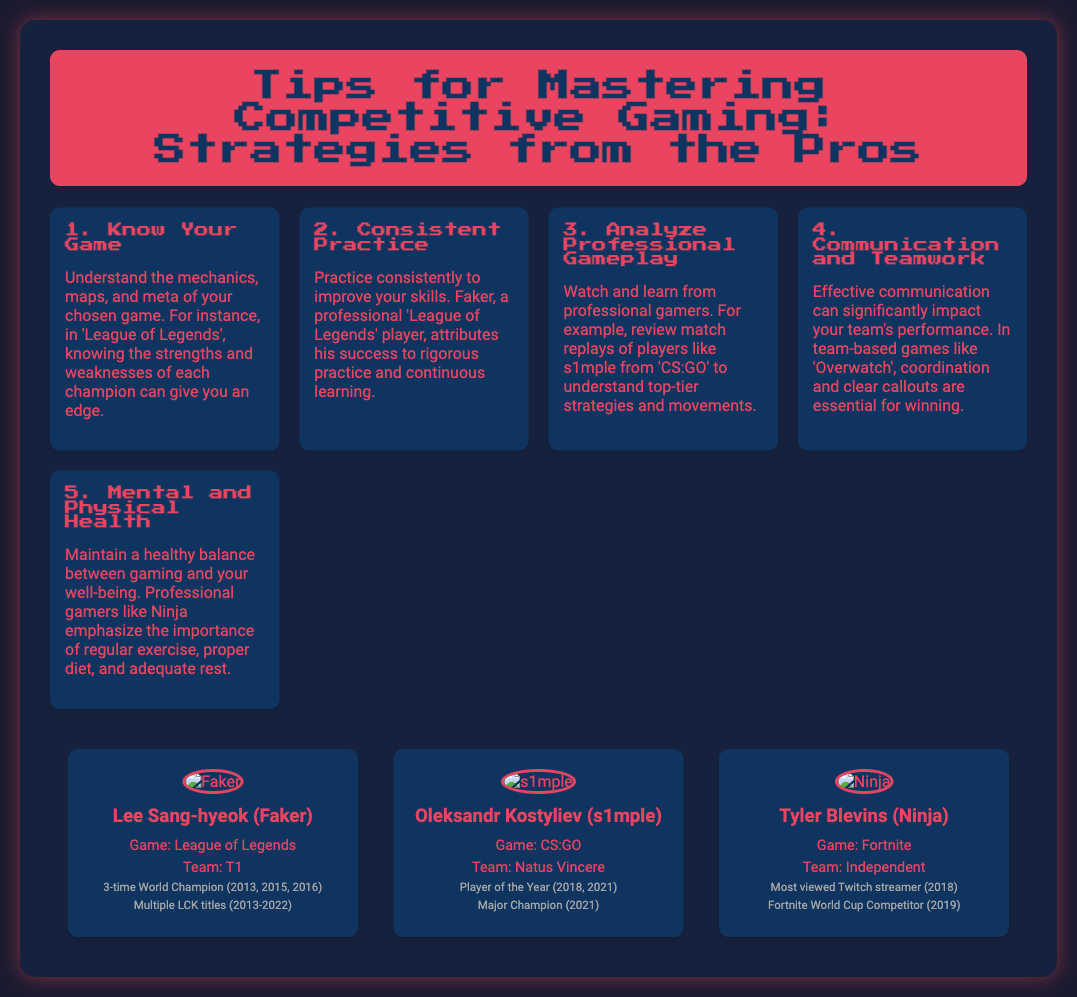what is the title of the flyer? The title of the flyer is prominently displayed at the top and reads "Tips for Mastering Competitive Gaming: Strategies from the Pros".
Answer: Tips for Mastering Competitive Gaming: Strategies from the Pros who is the professional gamer associated with 'League of Legends'? The document provides a profile of Lee Sang-hyeok, also known as Faker, who is associated with 'League of Legends'.
Answer: Lee Sang-hyeok (Faker) what game does Oleksandr Kostyliev play? Oleksandr Kostyliev's profile states that he plays 'CS:GO'.
Answer: CS:GO how many times has Faker been a World Champion? The achievements listed in Faker's profile indicate he has been a World Champion 3 times.
Answer: 3 which pro emphasizes mental and physical health? The flyer mentions that Ninja emphasizes the importance of regular exercise, proper diet, and adequate rest for maintaining mental and physical health.
Answer: Ninja what is a key aspect of gameplay highlighted for team-based games? The flyer under the tip for communication and teamwork highlights effective communication as a key aspect for team-based games like 'Overwatch'.
Answer: Effective communication what strategy is suggested for improving skills? The document suggests that practicing consistently is crucial for improving gaming skills, as attributed to Faker.
Answer: Consistent practice what year did s1mple win Player of the Year? According to the profile of s1mple, he won Player of the Year in both 2018 and 2021.
Answer: 2018, 2021 what game's meta should players understand? The flyer points out that players should understand the mechanics, maps, and meta of their chosen game, using 'League of Legends' as an example.
Answer: League of Legends 